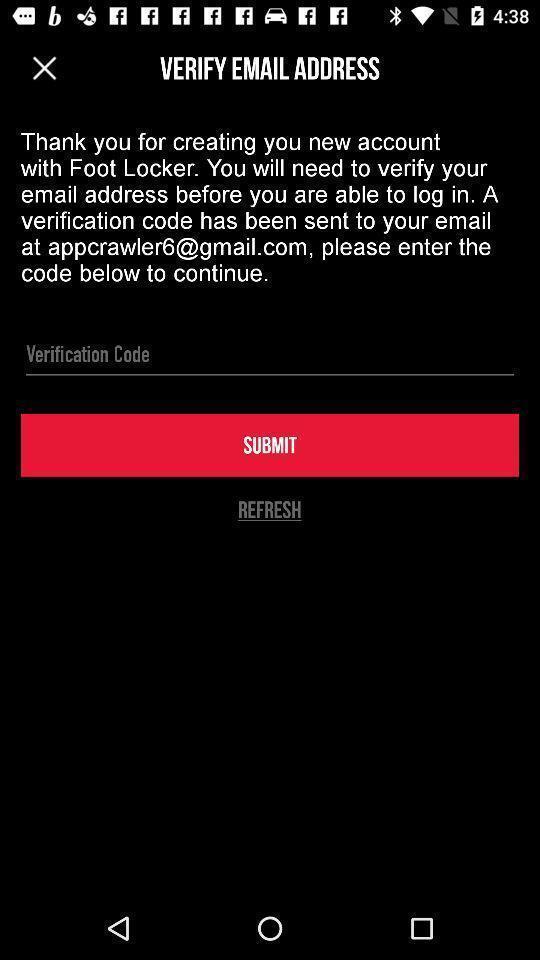Summarize the main components in this picture. Page to verify email address through verification code. 